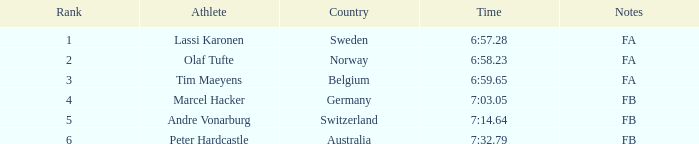Which athlete is from Norway? Olaf Tufte. 